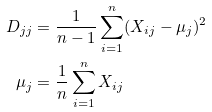Convert formula to latex. <formula><loc_0><loc_0><loc_500><loc_500>D _ { j j } & = \frac { 1 } { n - 1 } \sum _ { i = 1 } ^ { n } ( X _ { i j } - \mu _ { j } ) ^ { 2 } \\ \mu _ { j } & = \frac { 1 } { n } \sum _ { i = 1 } ^ { n } X _ { i j }</formula> 